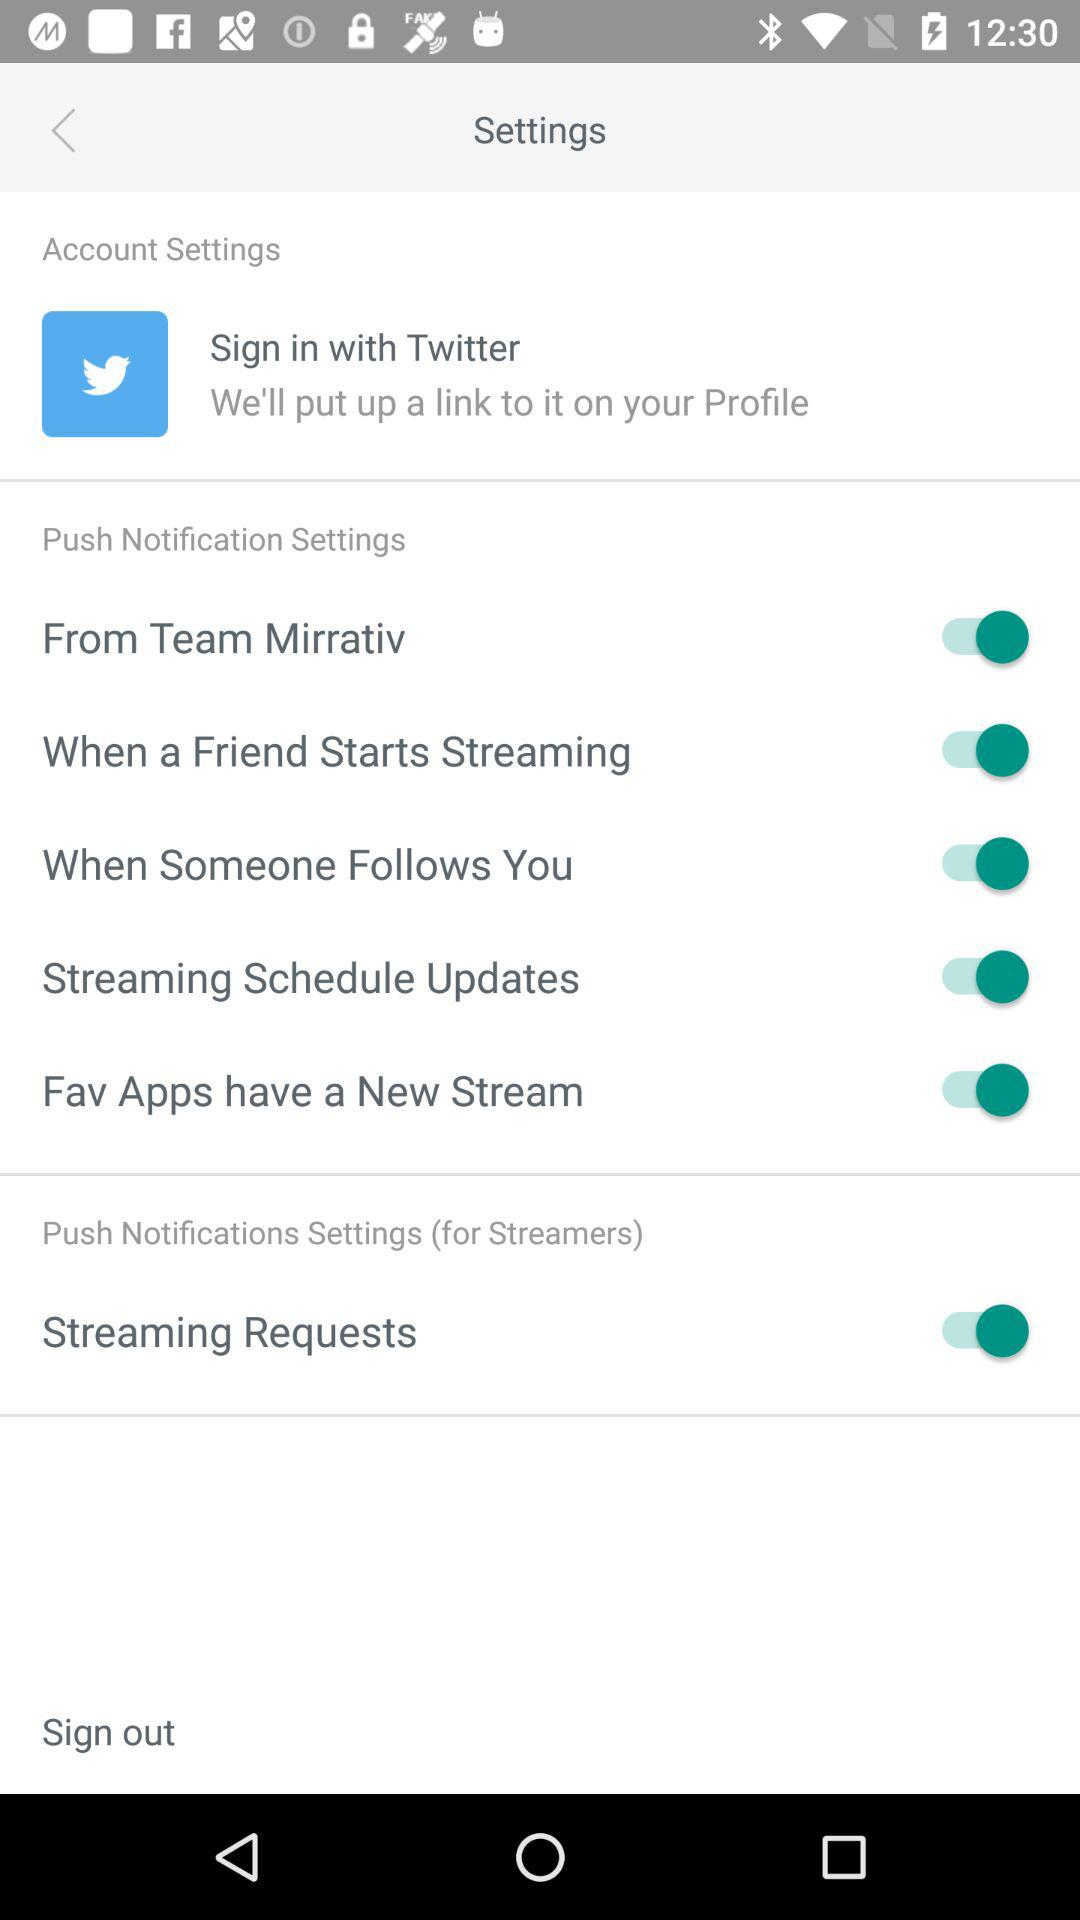What is the status of the "From Team Mirrativ"?
Answer the question using a single word or phrase. The status of "From Team Mirrativ" is "on." 